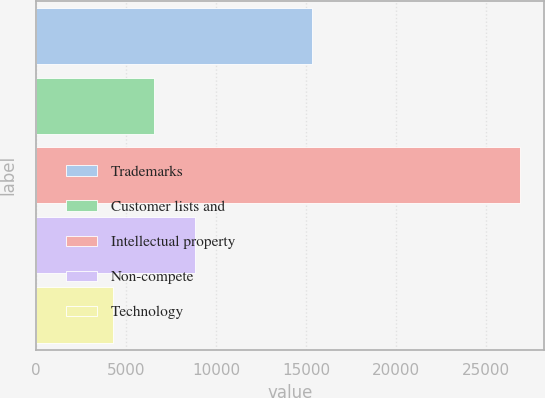<chart> <loc_0><loc_0><loc_500><loc_500><bar_chart><fcel>Trademarks<fcel>Customer lists and<fcel>Intellectual property<fcel>Non-compete<fcel>Technology<nl><fcel>15315<fcel>6567.6<fcel>26859<fcel>8822.2<fcel>4313<nl></chart> 